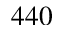<formula> <loc_0><loc_0><loc_500><loc_500>4 4 0</formula> 